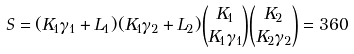<formula> <loc_0><loc_0><loc_500><loc_500>S = ( K _ { 1 } \gamma _ { 1 } + L _ { 1 } ) ( K _ { 1 } \gamma _ { 2 } + L _ { 2 } ) \binom { K _ { 1 } } { K _ { 1 } \gamma _ { 1 } } \binom { K _ { 2 } } { K _ { 2 } \gamma _ { 2 } } = 3 6 0</formula> 